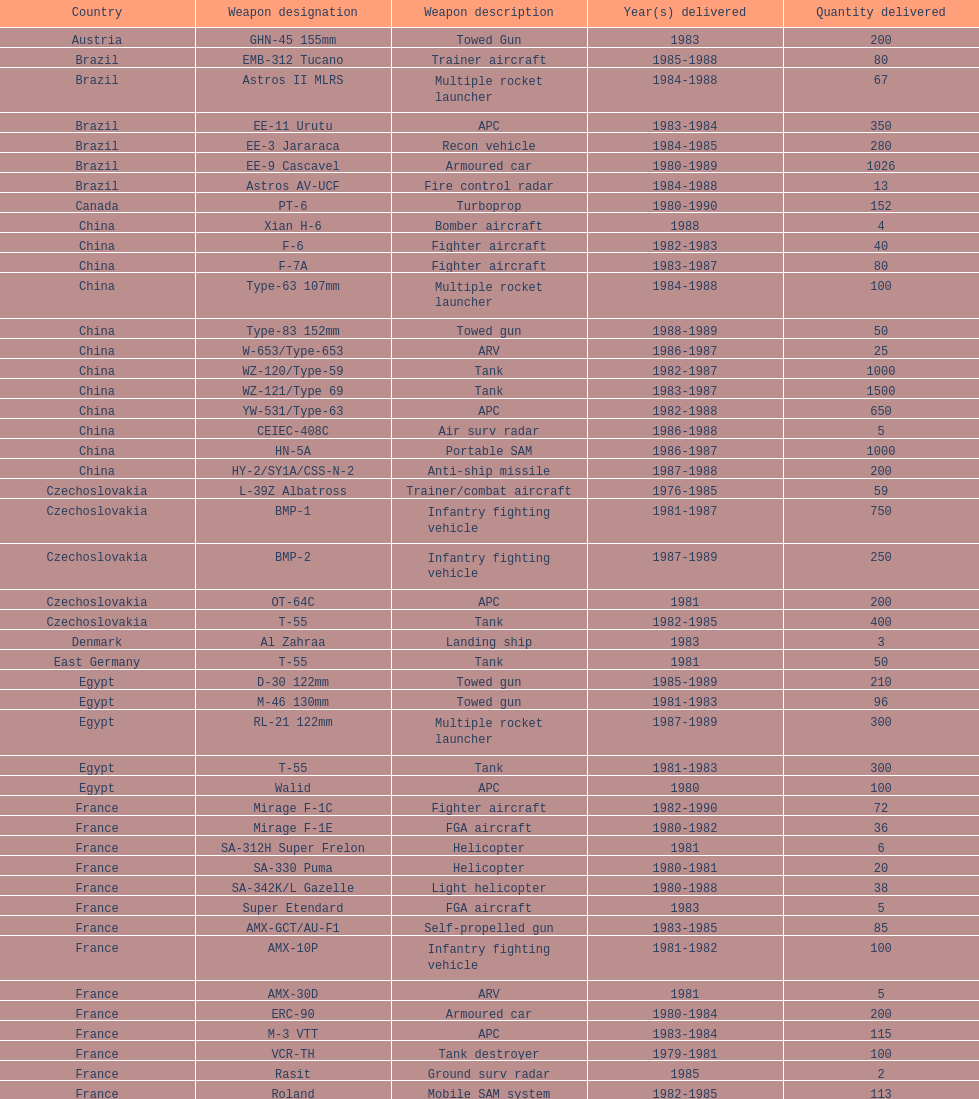Can you provide the total count of tanks that iraq has purchased from china? 2500. 